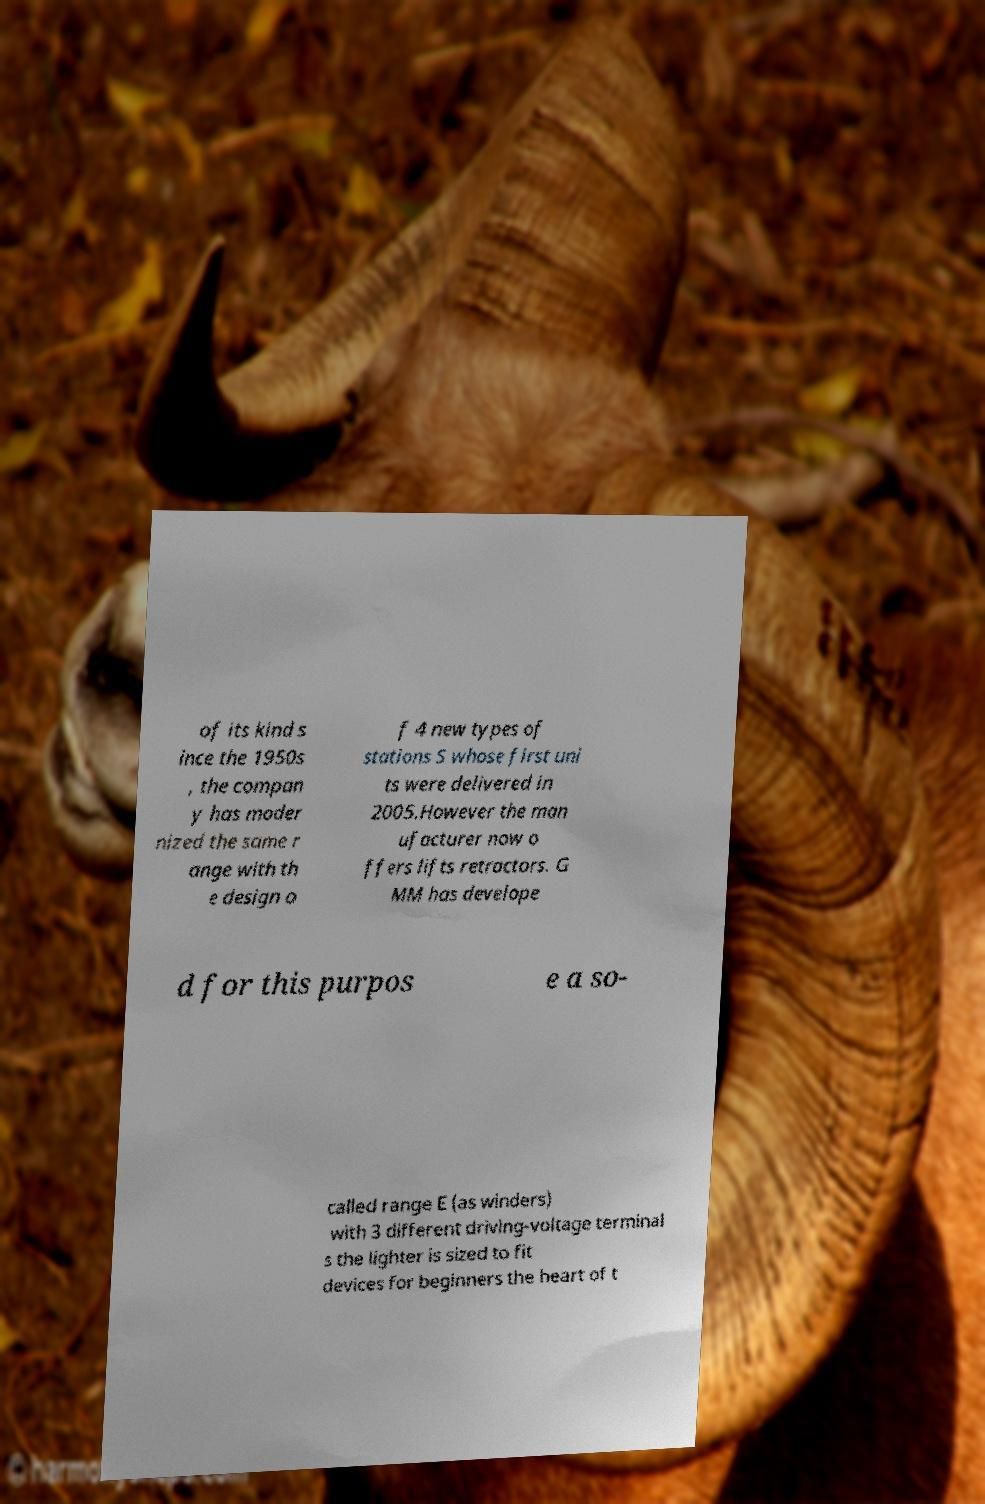Could you extract and type out the text from this image? of its kind s ince the 1950s , the compan y has moder nized the same r ange with th e design o f 4 new types of stations S whose first uni ts were delivered in 2005.However the man ufacturer now o ffers lifts retractors. G MM has develope d for this purpos e a so- called range E (as winders) with 3 different driving-voltage terminal s the lighter is sized to fit devices for beginners the heart of t 